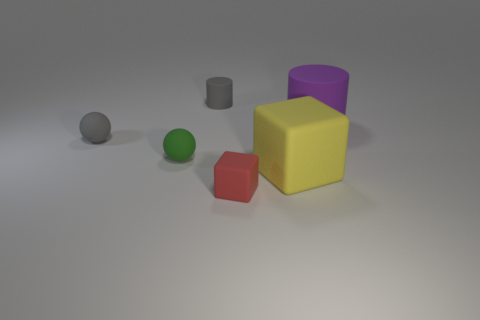Is the number of tiny red things in front of the large cube greater than the number of tiny gray rubber things that are to the right of the large rubber cylinder?
Ensure brevity in your answer.  Yes. How many other objects are there of the same size as the red thing?
Make the answer very short. 3. What size is the sphere that is in front of the tiny matte ball that is behind the small green ball?
Your answer should be very brief. Small. What number of tiny things are rubber cubes or gray rubber cylinders?
Offer a very short reply. 2. What is the size of the rubber cube that is to the left of the big yellow block in front of the large object behind the gray matte sphere?
Provide a succinct answer. Small. Is there any other thing of the same color as the small block?
Your answer should be very brief. No. What is the material of the tiny gray object that is left of the gray thing that is behind the tiny gray matte thing left of the small gray matte cylinder?
Offer a terse response. Rubber. Do the red rubber thing and the large yellow matte thing have the same shape?
Give a very brief answer. Yes. How many matte things are to the right of the small green sphere and on the left side of the large yellow matte block?
Offer a very short reply. 2. There is a tiny rubber thing that is right of the tiny cylinder that is on the left side of the purple cylinder; what color is it?
Ensure brevity in your answer.  Red. 